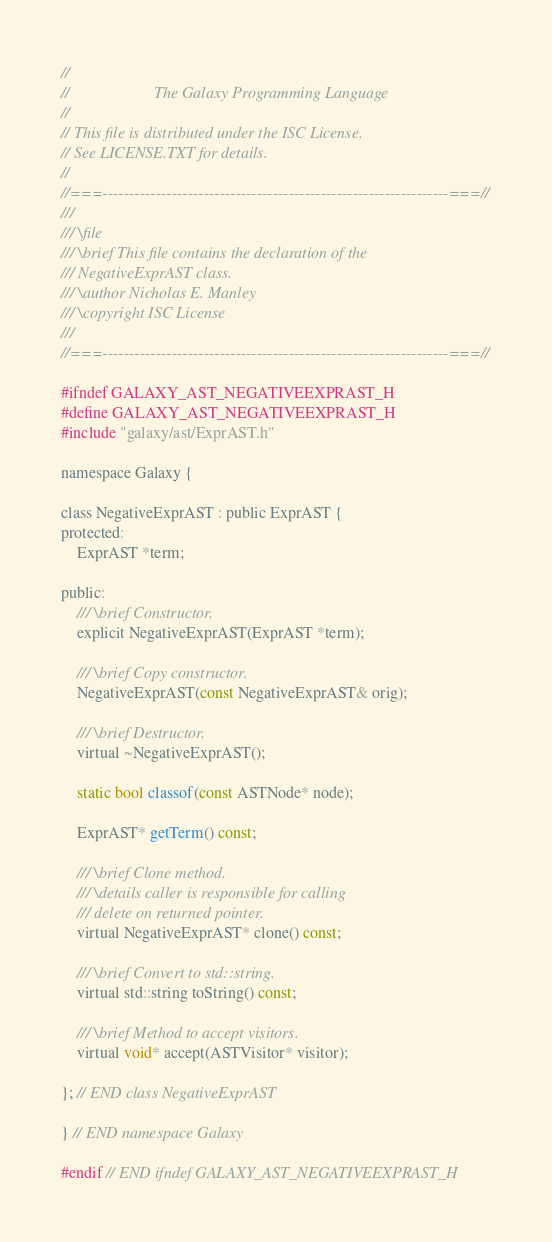<code> <loc_0><loc_0><loc_500><loc_500><_C_>//
//                     The Galaxy Programming Language
//
// This file is distributed under the ISC License.
// See LICENSE.TXT for details.
//
//===-----------------------------------------------------------------===//
///
/// \file
/// \brief This file contains the declaration of the
/// NegativeExprAST class.
/// \author Nicholas E. Manley
/// \copyright ISC License
///
//===-----------------------------------------------------------------===//

#ifndef GALAXY_AST_NEGATIVEEXPRAST_H
#define GALAXY_AST_NEGATIVEEXPRAST_H
#include "galaxy/ast/ExprAST.h"

namespace Galaxy {

class NegativeExprAST : public ExprAST {
protected:
    ExprAST *term;

public:
    /// \brief Constructor.
    explicit NegativeExprAST(ExprAST *term);

    /// \brief Copy constructor.
    NegativeExprAST(const NegativeExprAST& orig);

    /// \brief Destructor.
    virtual ~NegativeExprAST();

    static bool classof(const ASTNode* node);

    ExprAST* getTerm() const;

    /// \brief Clone method.
    /// \details caller is responsible for calling
    /// delete on returned pointer.
    virtual NegativeExprAST* clone() const;

    /// \brief Convert to std::string.
    virtual std::string toString() const;

    /// \brief Method to accept visitors.
    virtual void* accept(ASTVisitor* visitor);

}; // END class NegativeExprAST

} // END namespace Galaxy

#endif // END ifndef GALAXY_AST_NEGATIVEEXPRAST_H
</code> 